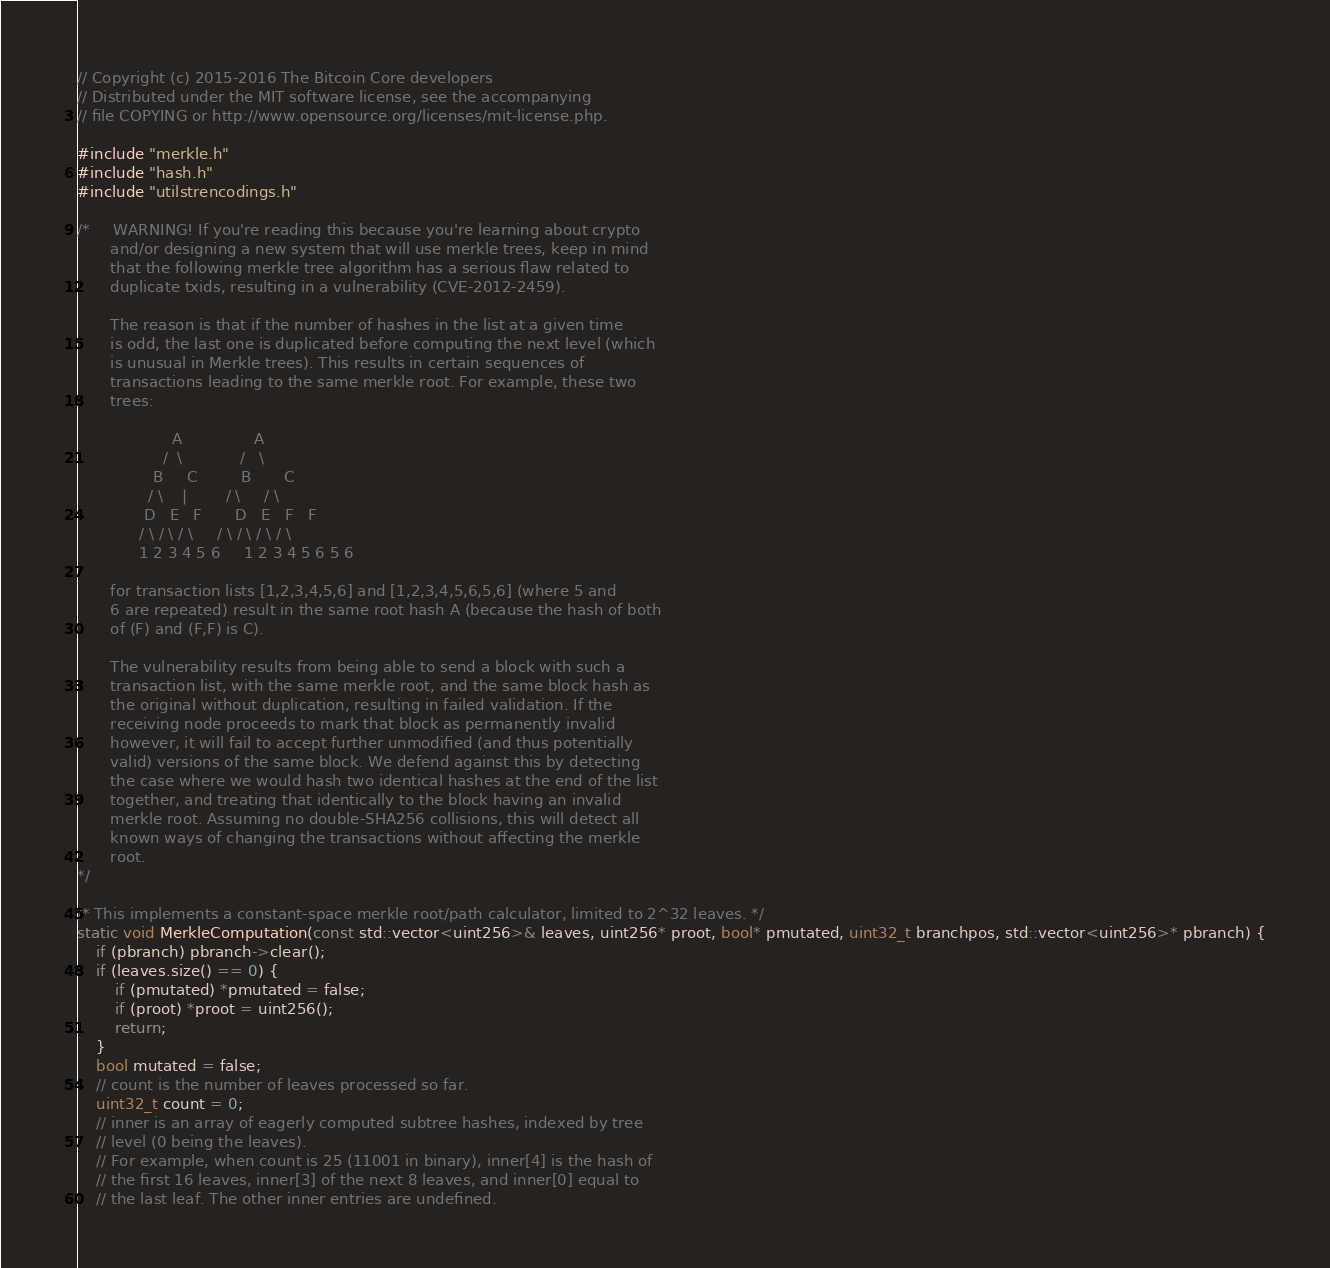Convert code to text. <code><loc_0><loc_0><loc_500><loc_500><_C++_>// Copyright (c) 2015-2016 The Bitcoin Core developers
// Distributed under the MIT software license, see the accompanying
// file COPYING or http://www.opensource.org/licenses/mit-license.php.

#include "merkle.h"
#include "hash.h"
#include "utilstrencodings.h"

/*     WARNING! If you're reading this because you're learning about crypto
       and/or designing a new system that will use merkle trees, keep in mind
       that the following merkle tree algorithm has a serious flaw related to
       duplicate txids, resulting in a vulnerability (CVE-2012-2459).

       The reason is that if the number of hashes in the list at a given time
       is odd, the last one is duplicated before computing the next level (which
       is unusual in Merkle trees). This results in certain sequences of
       transactions leading to the same merkle root. For example, these two
       trees:

                    A               A
                  /  \            /   \
                B     C         B       C
               / \    |        / \     / \
              D   E   F       D   E   F   F
             / \ / \ / \     / \ / \ / \ / \
             1 2 3 4 5 6     1 2 3 4 5 6 5 6

       for transaction lists [1,2,3,4,5,6] and [1,2,3,4,5,6,5,6] (where 5 and
       6 are repeated) result in the same root hash A (because the hash of both
       of (F) and (F,F) is C).

       The vulnerability results from being able to send a block with such a
       transaction list, with the same merkle root, and the same block hash as
       the original without duplication, resulting in failed validation. If the
       receiving node proceeds to mark that block as permanently invalid
       however, it will fail to accept further unmodified (and thus potentially
       valid) versions of the same block. We defend against this by detecting
       the case where we would hash two identical hashes at the end of the list
       together, and treating that identically to the block having an invalid
       merkle root. Assuming no double-SHA256 collisions, this will detect all
       known ways of changing the transactions without affecting the merkle
       root.
*/

/* This implements a constant-space merkle root/path calculator, limited to 2^32 leaves. */
static void MerkleComputation(const std::vector<uint256>& leaves, uint256* proot, bool* pmutated, uint32_t branchpos, std::vector<uint256>* pbranch) {
    if (pbranch) pbranch->clear();
    if (leaves.size() == 0) {
        if (pmutated) *pmutated = false;
        if (proot) *proot = uint256();
        return;
    }
    bool mutated = false;
    // count is the number of leaves processed so far.
    uint32_t count = 0;
    // inner is an array of eagerly computed subtree hashes, indexed by tree
    // level (0 being the leaves).
    // For example, when count is 25 (11001 in binary), inner[4] is the hash of
    // the first 16 leaves, inner[3] of the next 8 leaves, and inner[0] equal to
    // the last leaf. The other inner entries are undefined.</code> 